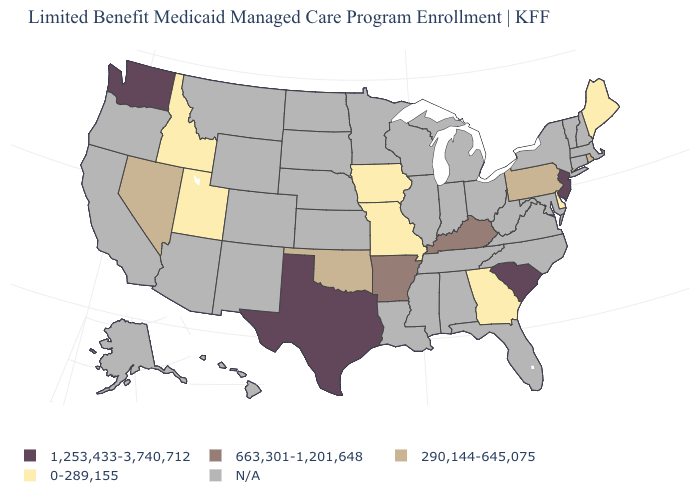Which states have the highest value in the USA?
Concise answer only. New Jersey, South Carolina, Texas, Washington. What is the value of Tennessee?
Concise answer only. N/A. Which states have the lowest value in the USA?
Short answer required. Delaware, Georgia, Idaho, Iowa, Maine, Missouri, Utah. What is the value of New Mexico?
Be succinct. N/A. Is the legend a continuous bar?
Answer briefly. No. Name the states that have a value in the range N/A?
Write a very short answer. Alabama, Alaska, Arizona, California, Colorado, Connecticut, Florida, Hawaii, Illinois, Indiana, Kansas, Louisiana, Maryland, Massachusetts, Michigan, Minnesota, Mississippi, Montana, Nebraska, New Hampshire, New Mexico, New York, North Carolina, North Dakota, Ohio, Oregon, South Dakota, Tennessee, Vermont, Virginia, West Virginia, Wisconsin, Wyoming. Which states have the highest value in the USA?
Answer briefly. New Jersey, South Carolina, Texas, Washington. Which states have the highest value in the USA?
Be succinct. New Jersey, South Carolina, Texas, Washington. What is the value of Iowa?
Concise answer only. 0-289,155. What is the value of Utah?
Quick response, please. 0-289,155. Name the states that have a value in the range 290,144-645,075?
Give a very brief answer. Nevada, Oklahoma, Pennsylvania, Rhode Island. 